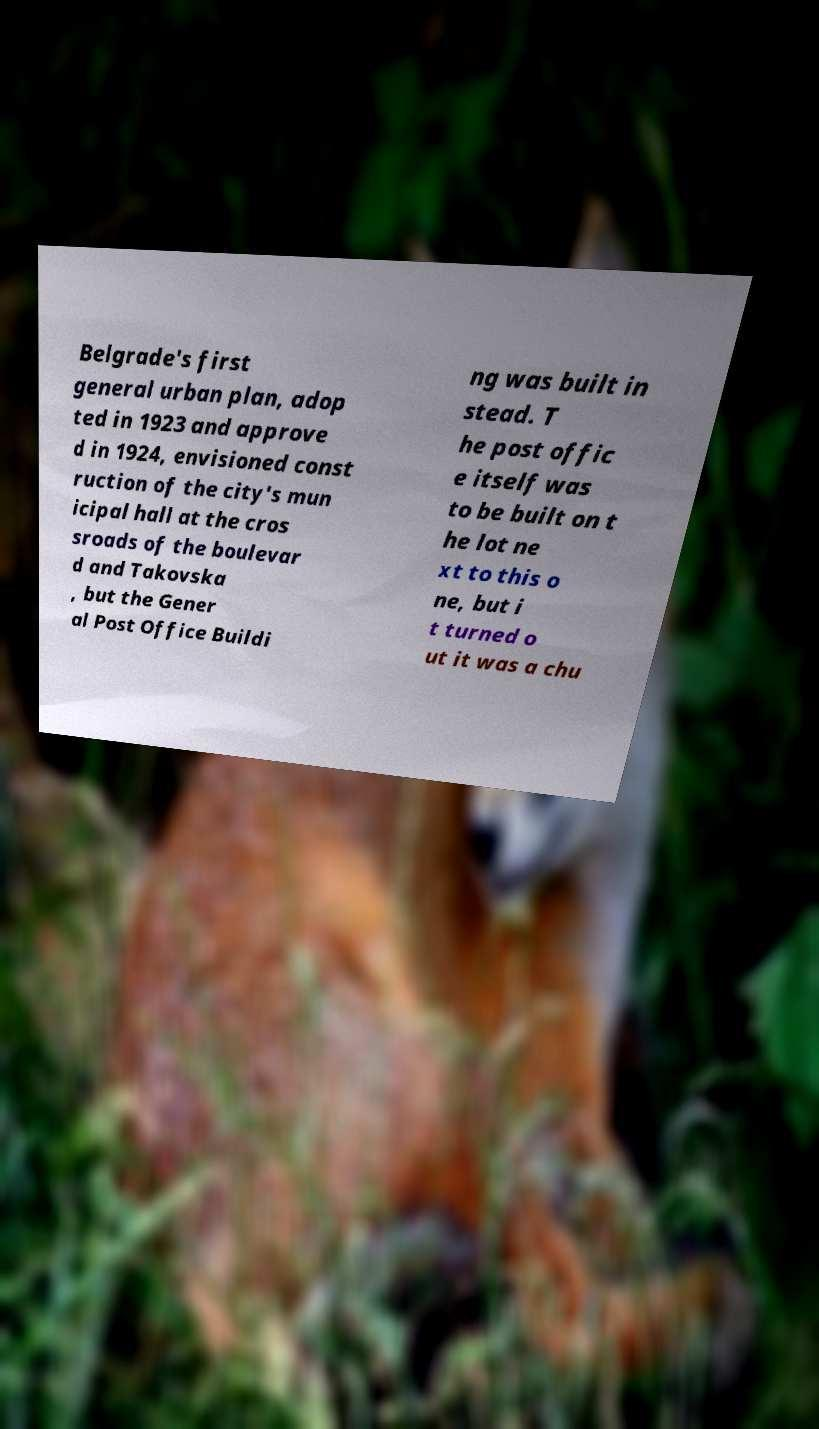Could you assist in decoding the text presented in this image and type it out clearly? Belgrade's first general urban plan, adop ted in 1923 and approve d in 1924, envisioned const ruction of the city's mun icipal hall at the cros sroads of the boulevar d and Takovska , but the Gener al Post Office Buildi ng was built in stead. T he post offic e itself was to be built on t he lot ne xt to this o ne, but i t turned o ut it was a chu 